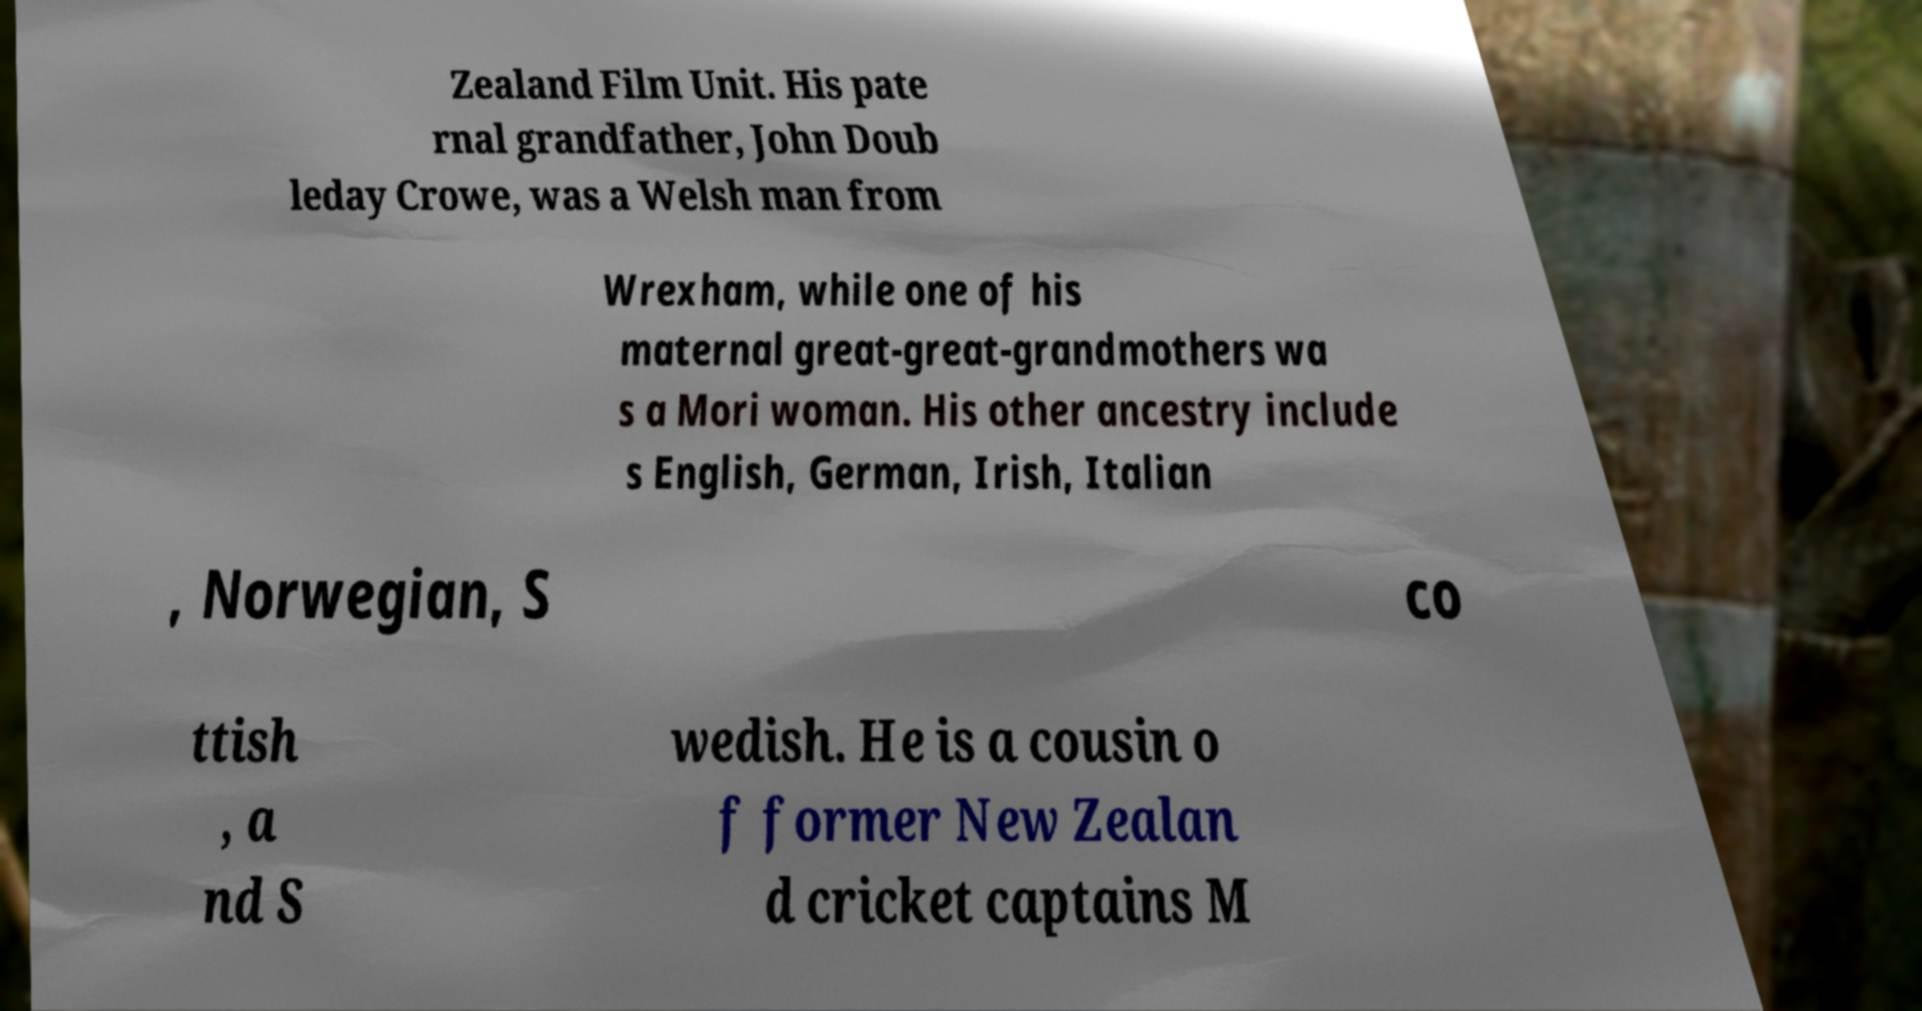For documentation purposes, I need the text within this image transcribed. Could you provide that? Zealand Film Unit. His pate rnal grandfather, John Doub leday Crowe, was a Welsh man from Wrexham, while one of his maternal great-great-grandmothers wa s a Mori woman. His other ancestry include s English, German, Irish, Italian , Norwegian, S co ttish , a nd S wedish. He is a cousin o f former New Zealan d cricket captains M 